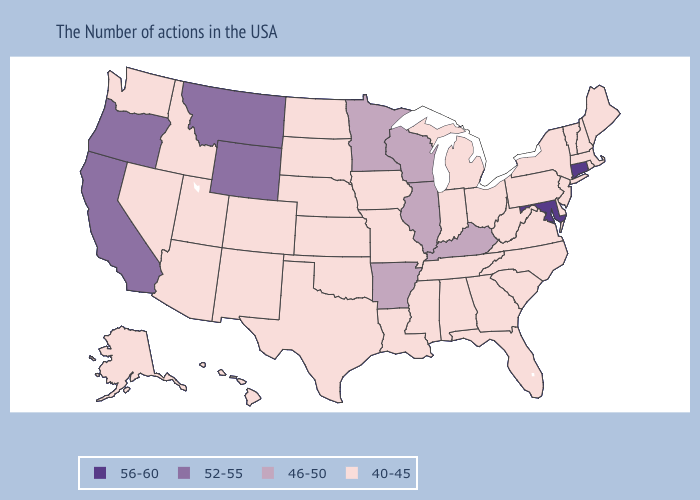Name the states that have a value in the range 40-45?
Keep it brief. Maine, Massachusetts, Rhode Island, New Hampshire, Vermont, New York, New Jersey, Delaware, Pennsylvania, Virginia, North Carolina, South Carolina, West Virginia, Ohio, Florida, Georgia, Michigan, Indiana, Alabama, Tennessee, Mississippi, Louisiana, Missouri, Iowa, Kansas, Nebraska, Oklahoma, Texas, South Dakota, North Dakota, Colorado, New Mexico, Utah, Arizona, Idaho, Nevada, Washington, Alaska, Hawaii. Among the states that border Colorado , does Wyoming have the lowest value?
Answer briefly. No. What is the lowest value in the USA?
Quick response, please. 40-45. Which states hav the highest value in the South?
Give a very brief answer. Maryland. Does Rhode Island have the highest value in the Northeast?
Short answer required. No. Does Kansas have the same value as New Hampshire?
Be succinct. Yes. What is the lowest value in states that border Idaho?
Concise answer only. 40-45. What is the lowest value in the USA?
Keep it brief. 40-45. What is the value of Florida?
Give a very brief answer. 40-45. Name the states that have a value in the range 52-55?
Keep it brief. Wyoming, Montana, California, Oregon. Which states have the highest value in the USA?
Write a very short answer. Connecticut, Maryland. What is the highest value in states that border California?
Quick response, please. 52-55. Among the states that border Arizona , does California have the highest value?
Quick response, please. Yes. What is the value of Washington?
Answer briefly. 40-45. What is the value of Illinois?
Be succinct. 46-50. 